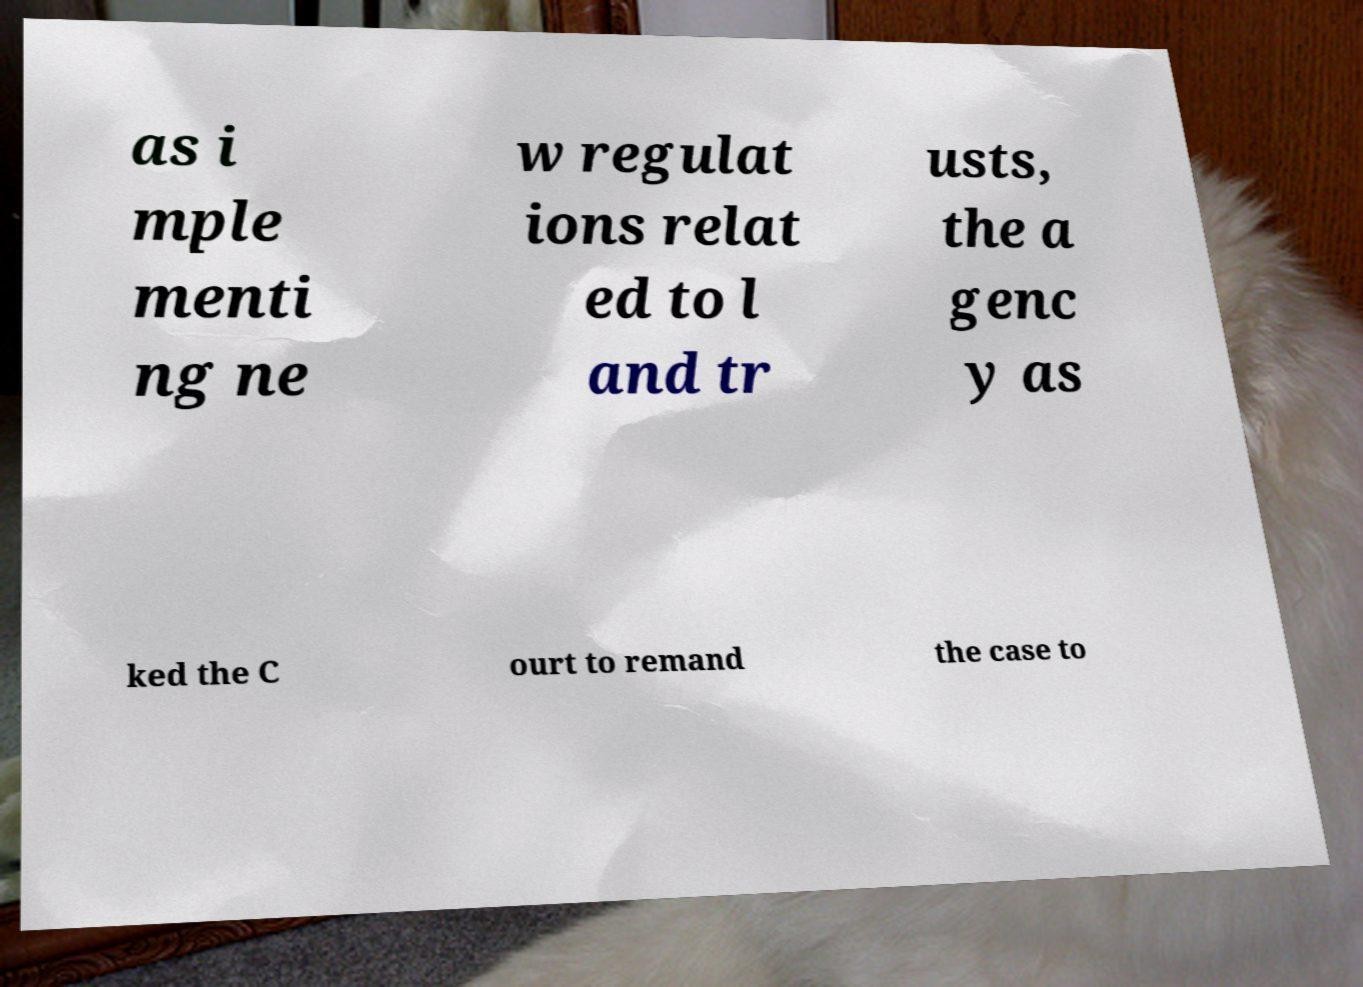What messages or text are displayed in this image? I need them in a readable, typed format. as i mple menti ng ne w regulat ions relat ed to l and tr usts, the a genc y as ked the C ourt to remand the case to 